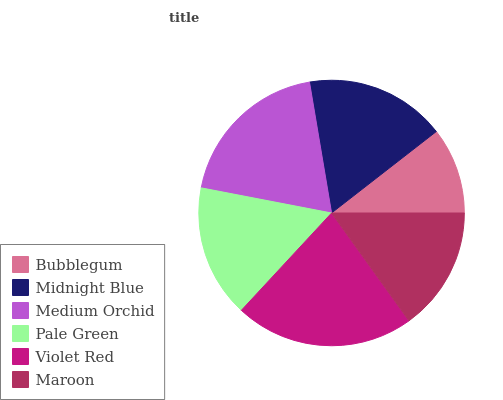Is Bubblegum the minimum?
Answer yes or no. Yes. Is Violet Red the maximum?
Answer yes or no. Yes. Is Midnight Blue the minimum?
Answer yes or no. No. Is Midnight Blue the maximum?
Answer yes or no. No. Is Midnight Blue greater than Bubblegum?
Answer yes or no. Yes. Is Bubblegum less than Midnight Blue?
Answer yes or no. Yes. Is Bubblegum greater than Midnight Blue?
Answer yes or no. No. Is Midnight Blue less than Bubblegum?
Answer yes or no. No. Is Midnight Blue the high median?
Answer yes or no. Yes. Is Pale Green the low median?
Answer yes or no. Yes. Is Medium Orchid the high median?
Answer yes or no. No. Is Maroon the low median?
Answer yes or no. No. 